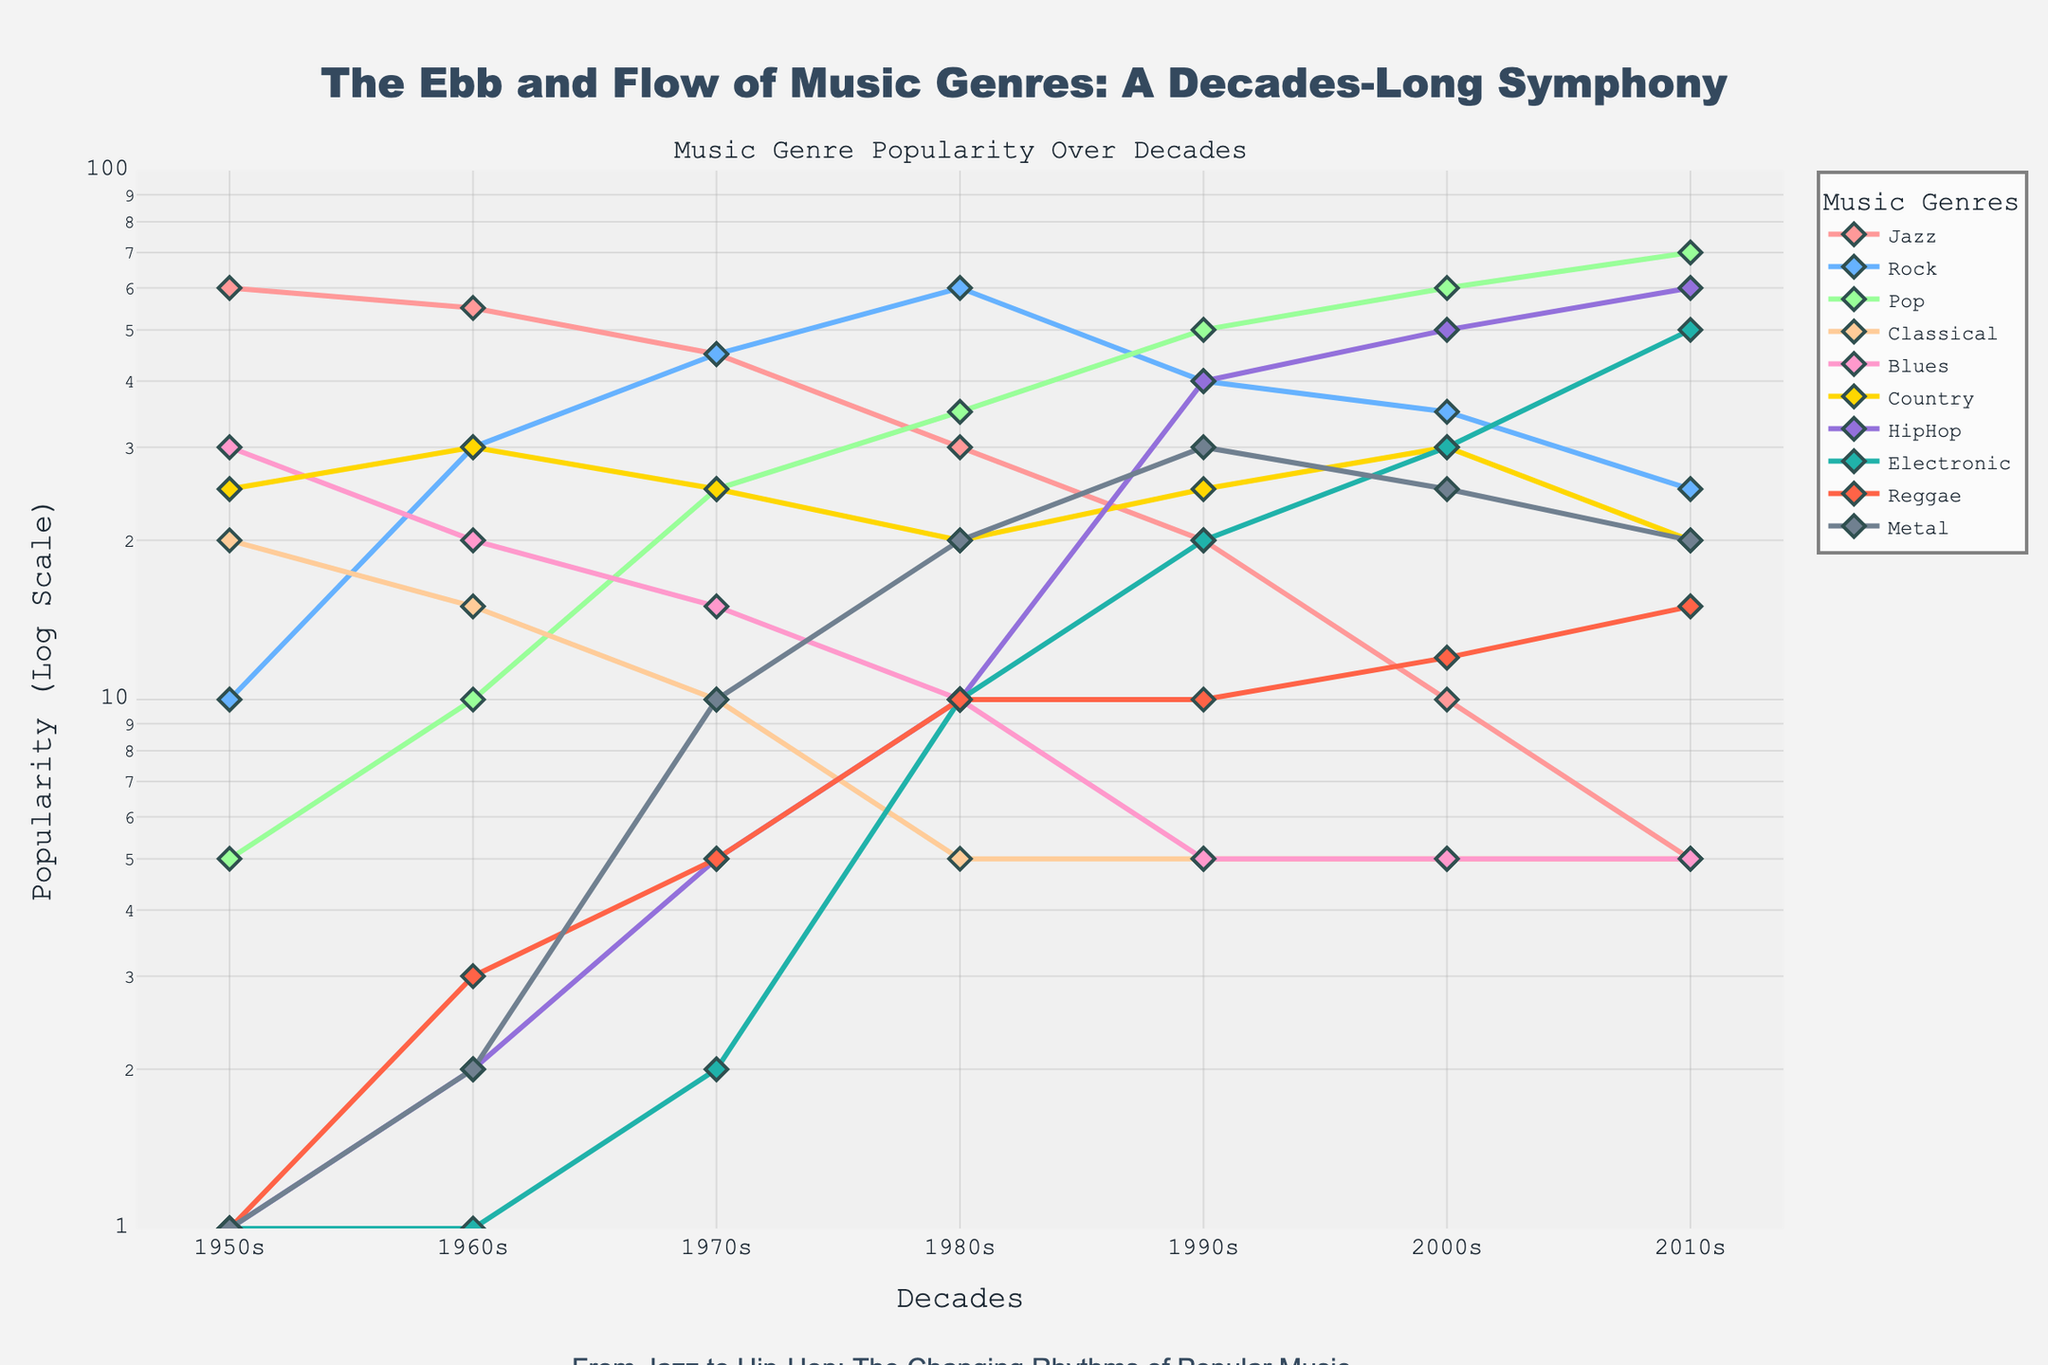What's the title of the figure? The title is prominently displayed at the top of the figure and reads "The Ebb and Flow of Music Genres: A Decades-Long Symphony".
Answer: The Ebb and Flow of Music Genres: A Decades-Long Symphony What is the y-axis labeled? The y-axis label is clearly indicated along the vertical axis and it reads "Popularity (Log Scale)".
Answer: Popularity (Log Scale) Which genre has the highest popularity in the 2010s? By examining the end of each line representing different genres on the right side (2010s), the highest point is for Pop.
Answer: Pop How did the popularity of HipHop change from the 1980s to the 2000s? Looking at the line for HipHop from the 1980s (10) to the 2000s (50), there is a significant increase in popularity.
Answer: Increased What is the overall trend of Classical music over the decades? Observing the line for Classical music from the 1950s to the 2010s, it shows a decrease and then stabilizes at a lower value post-1980s.
Answer: Decreasing then stable Which decade had the highest diversity in genre popularity? By comparing the spread and values of popularity across genres for each decade, the 1980s show a wide range of values among different genres.
Answer: 1980s Which genre had the least change in popularity over the decades? By assessing each genre's line, Country music shows the least variation as its line remains relatively flat.
Answer: Country Are there any genres that started with very low popularity in the 1950s and increased significantly by the 2010s? By observing the lines from the lower values in the 1950s to higher values in the 2010s, HipHop and Electronic music both start near 1 and rise to 60 and 50, respectively.
Answer: HipHop, Electronic Compare the popularity trends of Rock and Metal. Rock shows an increase from the 1950s, peaks in the 1980s, then decreases, while Metal shows a slower rise from the 1960s and 1970s, peaks in the 1990s, and then decreases.
Answer: Different peak periods 